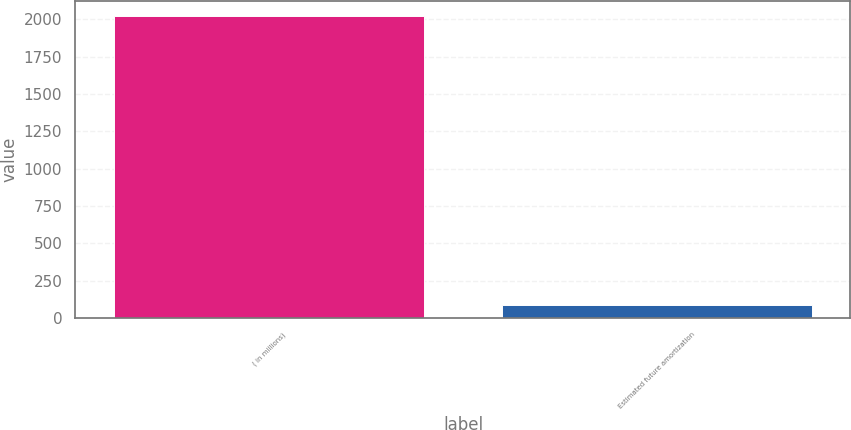Convert chart to OTSL. <chart><loc_0><loc_0><loc_500><loc_500><bar_chart><fcel>( in millions)<fcel>Estimated future amortization<nl><fcel>2021<fcel>85<nl></chart> 